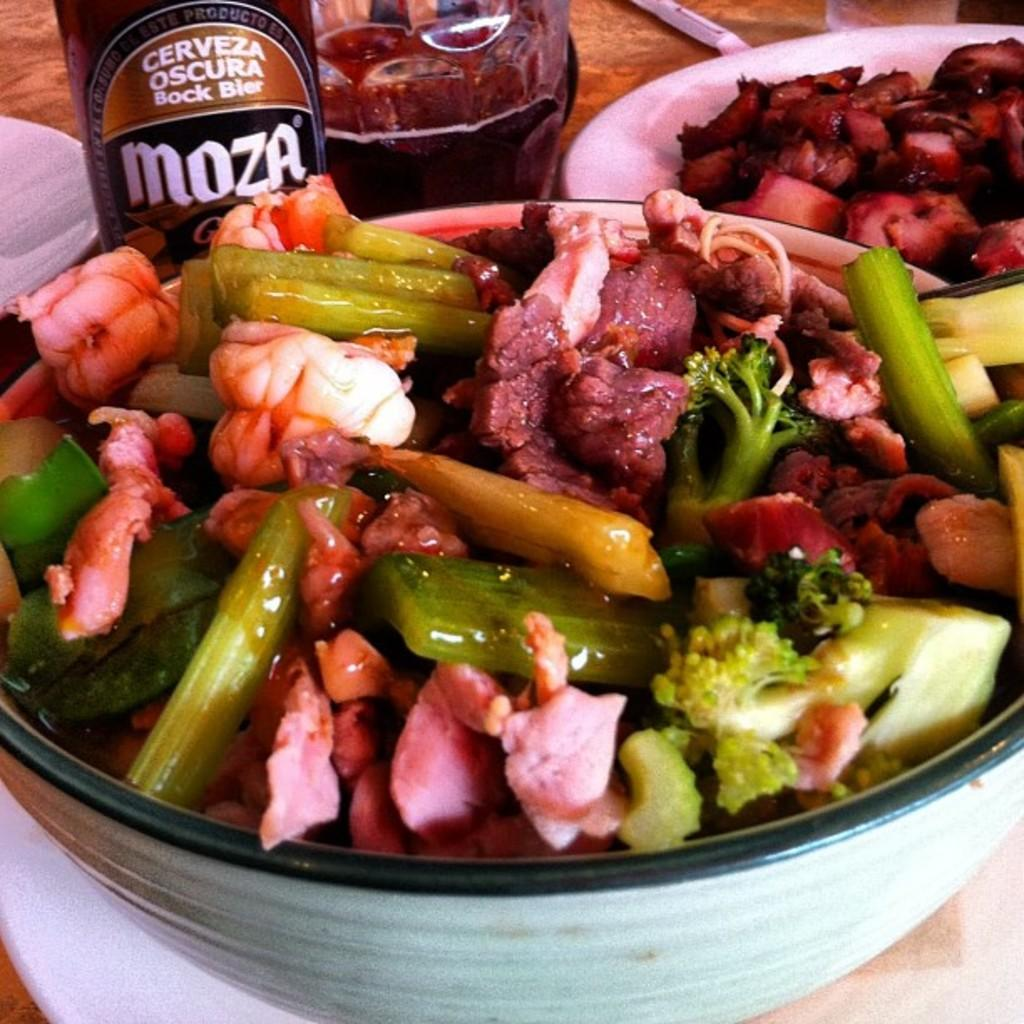What type of container is holding food in the image? There is food in a bowl and on a plate in the image. What other items are near the bowl in the image? There is a bottle and a glass beside the bowl in the image. What type of camera is capturing the scene in the image? There is no camera visible in the image, and it does not depict a scene being captured. 